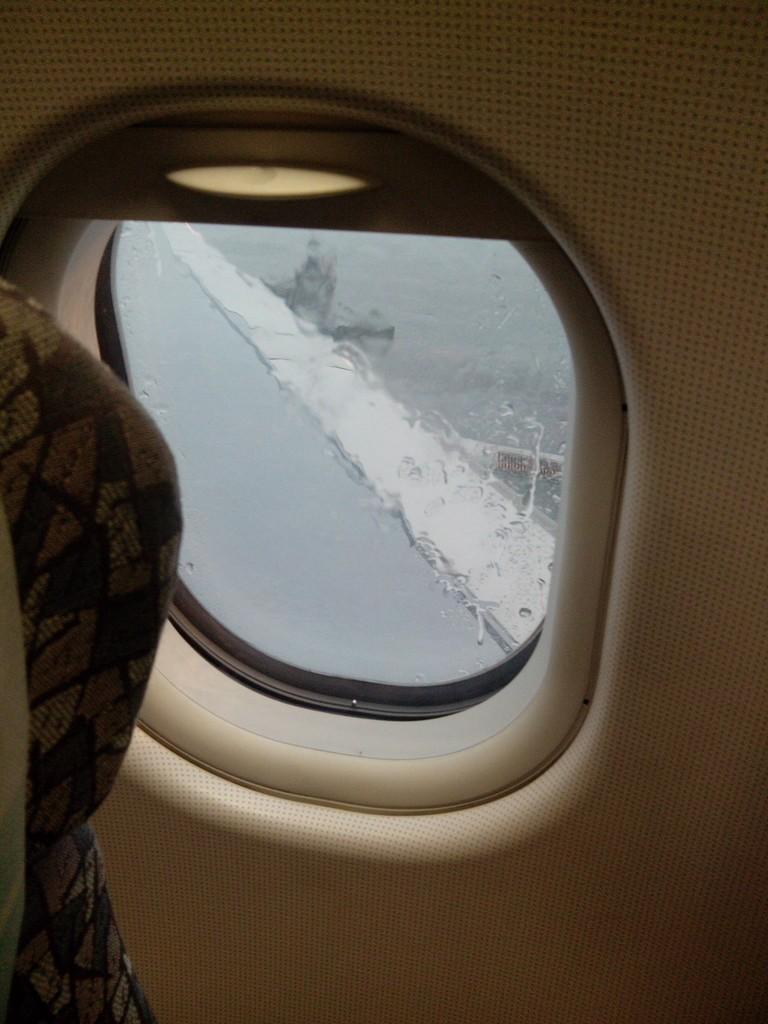What is present in the image that people can sit on? There is a seat in the image. What can be seen through the window in the image? The window belongs to a vehicle, but the specific view is not mentioned in the facts. What type of vehicle might the window belong to? Since the window belongs to a vehicle, it could be a car, bus, train, or any other type of vehicle with windows. How many cakes are displayed on the seat in the image? There is no mention of cakes in the image, so we cannot determine their presence or quantity. What advice does the father give to the passengers in the image? There is no mention of a father or passengers in the image, so we cannot determine any advice given. 